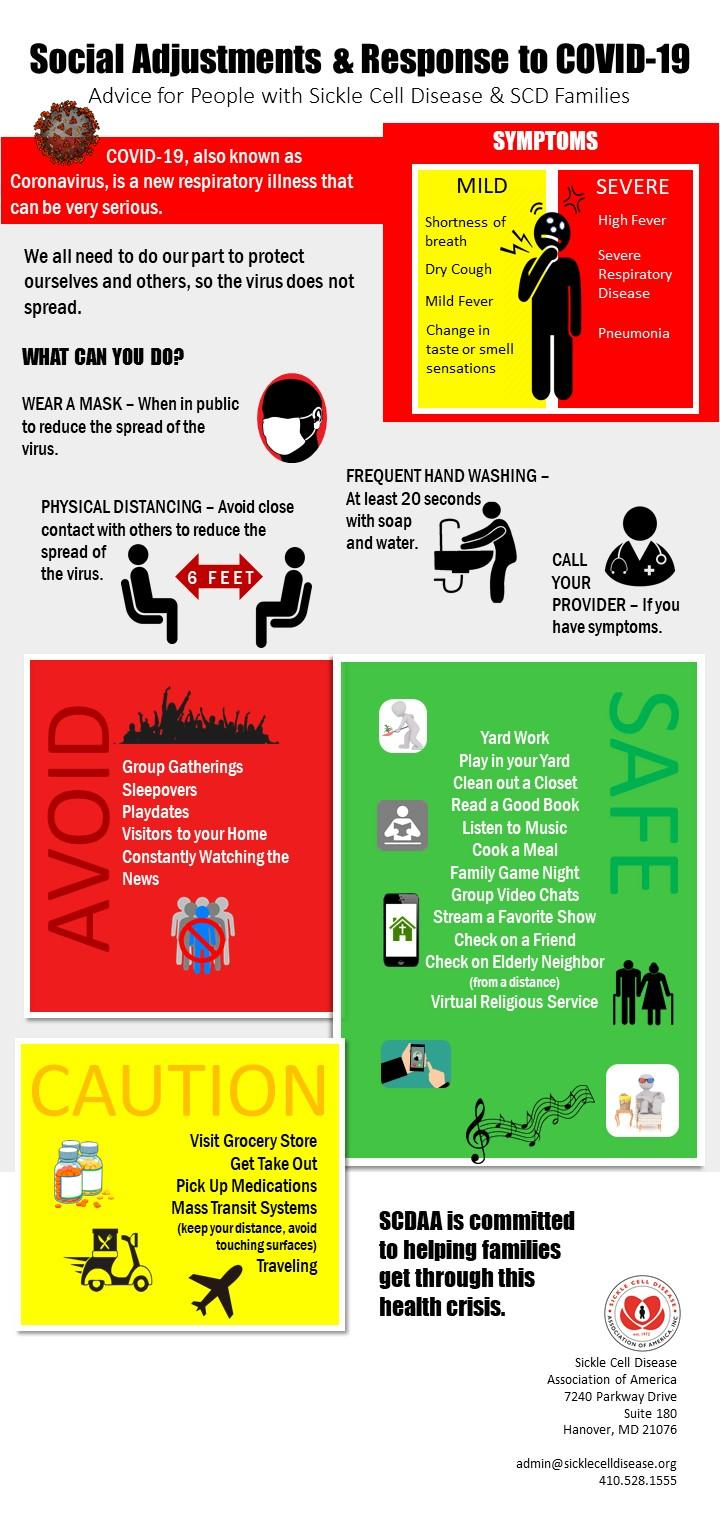Indicate a few pertinent items in this graphic. It is crucial to take precautionary measures other than physical distancing and frequent hand washing to avoid the spread of coronavirus. One such measure is to wear a mask, which helps to prevent the spread of the virus. The Centers for Disease Control and Prevention (CDC) recommends maintaining a safe distance of six feet or more with others to avoid the spread of COVID-19. COVID-19 can cause severe symptoms other than high fever and pneumonia, such as severe respiratory disease. 